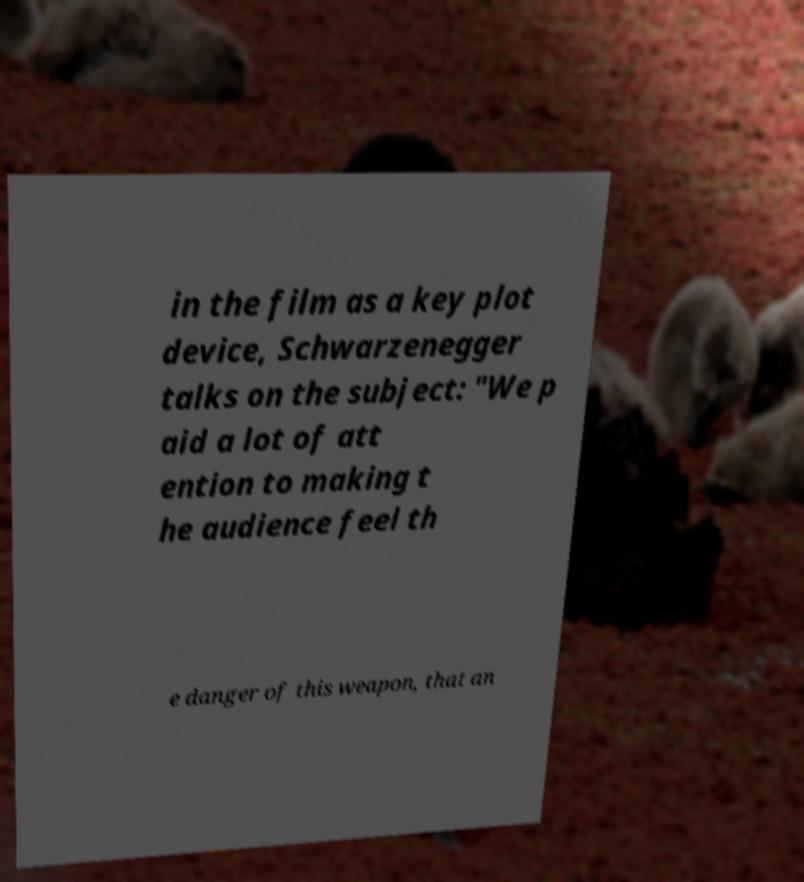Could you extract and type out the text from this image? in the film as a key plot device, Schwarzenegger talks on the subject: "We p aid a lot of att ention to making t he audience feel th e danger of this weapon, that an 